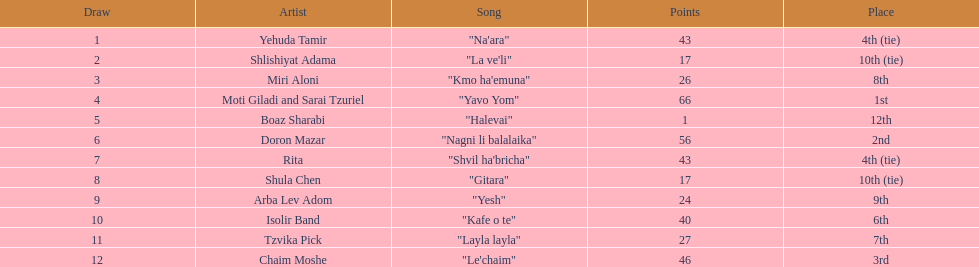Which artist had nearly no points? Boaz Sharabi. 